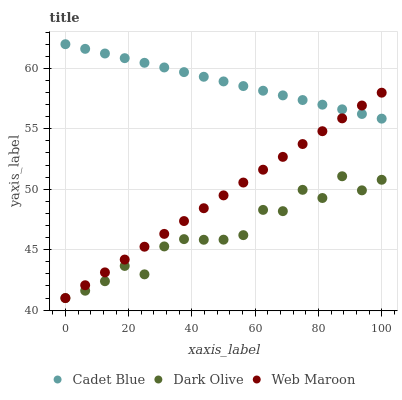Does Dark Olive have the minimum area under the curve?
Answer yes or no. Yes. Does Cadet Blue have the maximum area under the curve?
Answer yes or no. Yes. Does Web Maroon have the minimum area under the curve?
Answer yes or no. No. Does Web Maroon have the maximum area under the curve?
Answer yes or no. No. Is Cadet Blue the smoothest?
Answer yes or no. Yes. Is Dark Olive the roughest?
Answer yes or no. Yes. Is Web Maroon the smoothest?
Answer yes or no. No. Is Web Maroon the roughest?
Answer yes or no. No. Does Dark Olive have the lowest value?
Answer yes or no. Yes. Does Cadet Blue have the lowest value?
Answer yes or no. No. Does Cadet Blue have the highest value?
Answer yes or no. Yes. Does Web Maroon have the highest value?
Answer yes or no. No. Is Dark Olive less than Cadet Blue?
Answer yes or no. Yes. Is Cadet Blue greater than Dark Olive?
Answer yes or no. Yes. Does Cadet Blue intersect Web Maroon?
Answer yes or no. Yes. Is Cadet Blue less than Web Maroon?
Answer yes or no. No. Is Cadet Blue greater than Web Maroon?
Answer yes or no. No. Does Dark Olive intersect Cadet Blue?
Answer yes or no. No. 